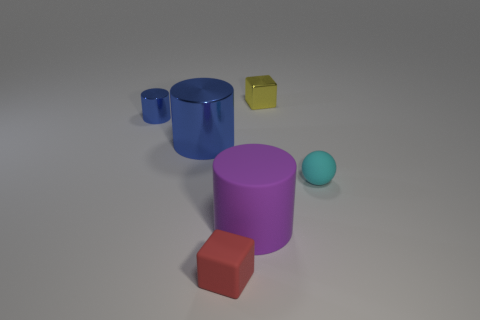Is there anything else that has the same material as the large purple thing?
Offer a very short reply. Yes. Is there a small yellow rubber object?
Your response must be concise. No. Does the matte sphere have the same color as the block behind the tiny blue object?
Make the answer very short. No. How big is the cylinder in front of the small matte thing that is to the right of the tiny rubber thing that is to the left of the shiny cube?
Make the answer very short. Large. How many cylinders are the same color as the big shiny thing?
Provide a short and direct response. 1. What number of things are matte spheres or cubes that are on the right side of the large rubber object?
Your response must be concise. 2. What is the color of the ball?
Provide a succinct answer. Cyan. What color is the small metal thing in front of the small yellow cube?
Keep it short and to the point. Blue. How many small cyan matte objects are in front of the thing to the right of the tiny yellow thing?
Your answer should be compact. 0. Does the sphere have the same size as the block behind the big purple object?
Provide a short and direct response. Yes. 